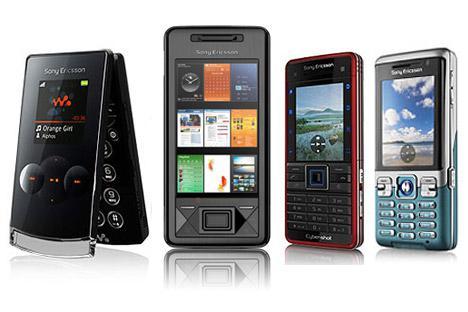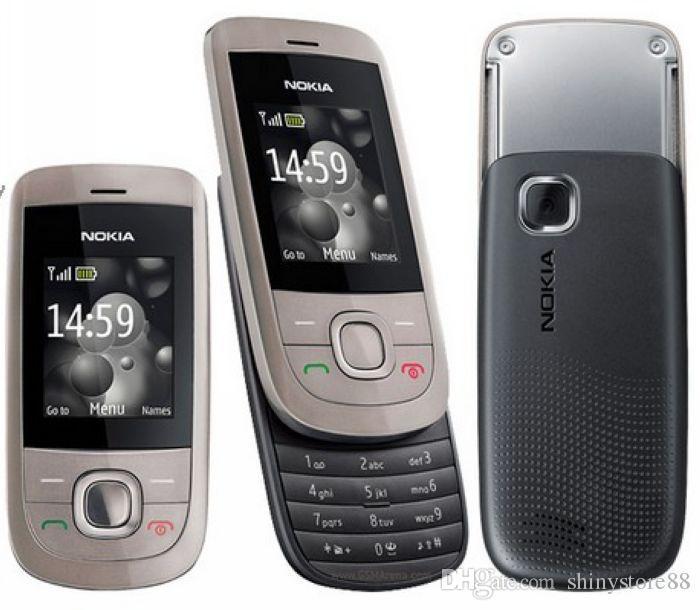The first image is the image on the left, the second image is the image on the right. For the images displayed, is the sentence "One image shows exactly three phones, and the other image shows a single row containing at least four phones." factually correct? Answer yes or no. Yes. The first image is the image on the left, the second image is the image on the right. Evaluate the accuracy of this statement regarding the images: "One of the pictures shows at least six phones side by side.". Is it true? Answer yes or no. No. 